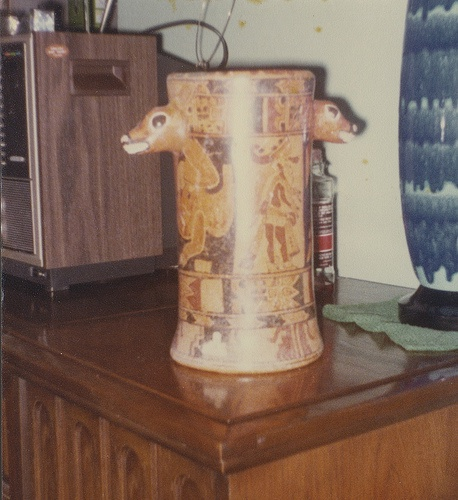Describe the objects in this image and their specific colors. I can see vase in gray and tan tones, tv in gray, brown, and black tones, vase in gray, black, darkblue, and darkgray tones, and bottle in gray, maroon, and darkgray tones in this image. 